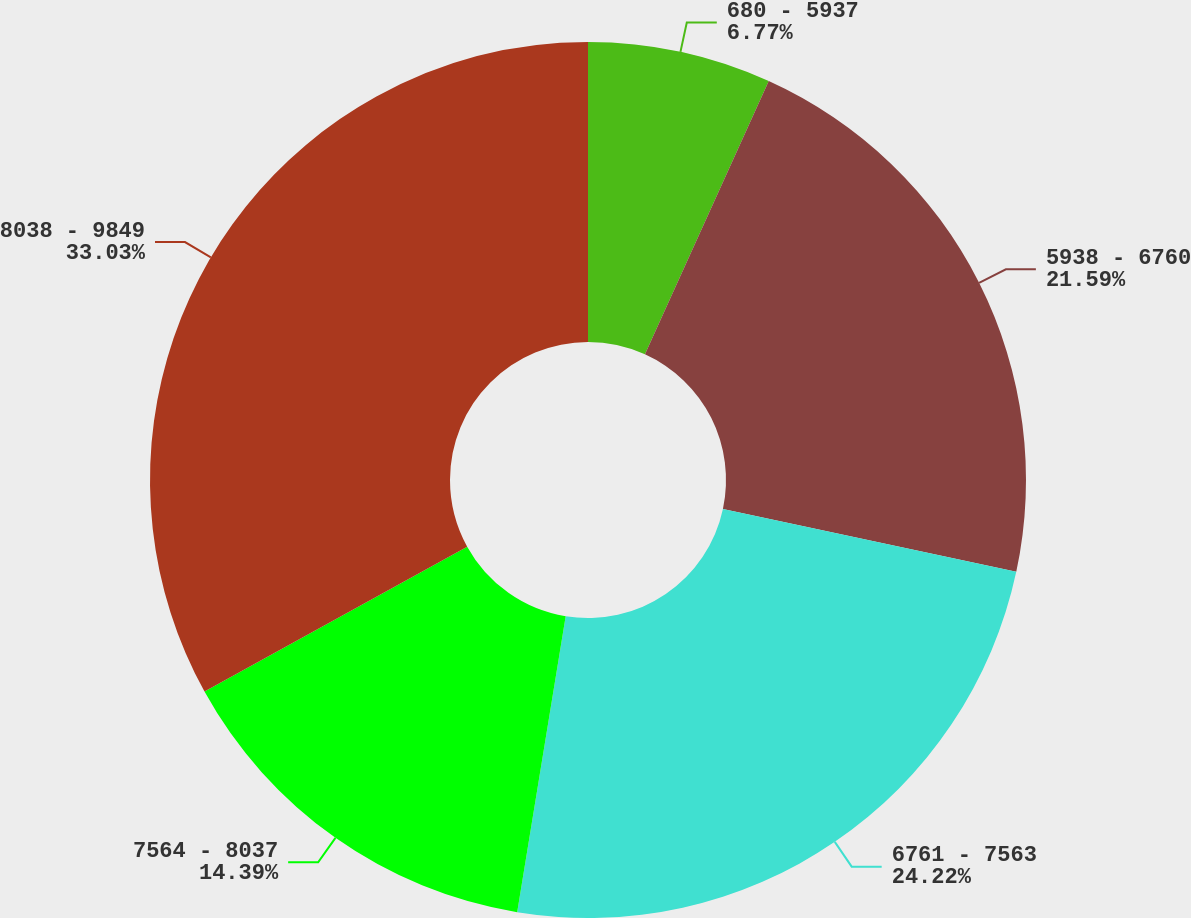Convert chart to OTSL. <chart><loc_0><loc_0><loc_500><loc_500><pie_chart><fcel>680 - 5937<fcel>5938 - 6760<fcel>6761 - 7563<fcel>7564 - 8037<fcel>8038 - 9849<nl><fcel>6.77%<fcel>21.59%<fcel>24.22%<fcel>14.39%<fcel>33.02%<nl></chart> 